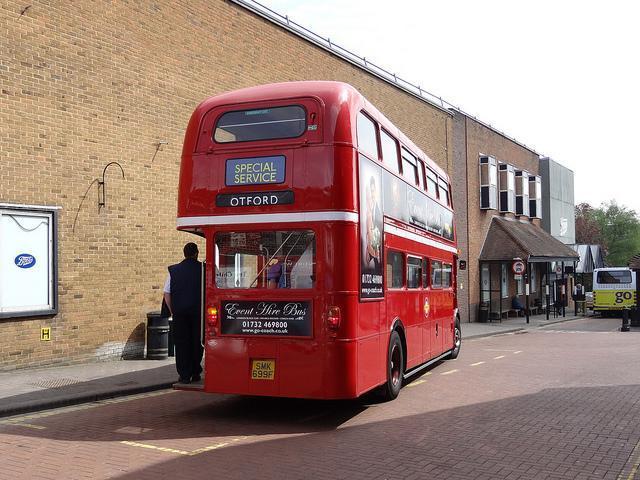How many levels does this bus have?
Give a very brief answer. 2. 